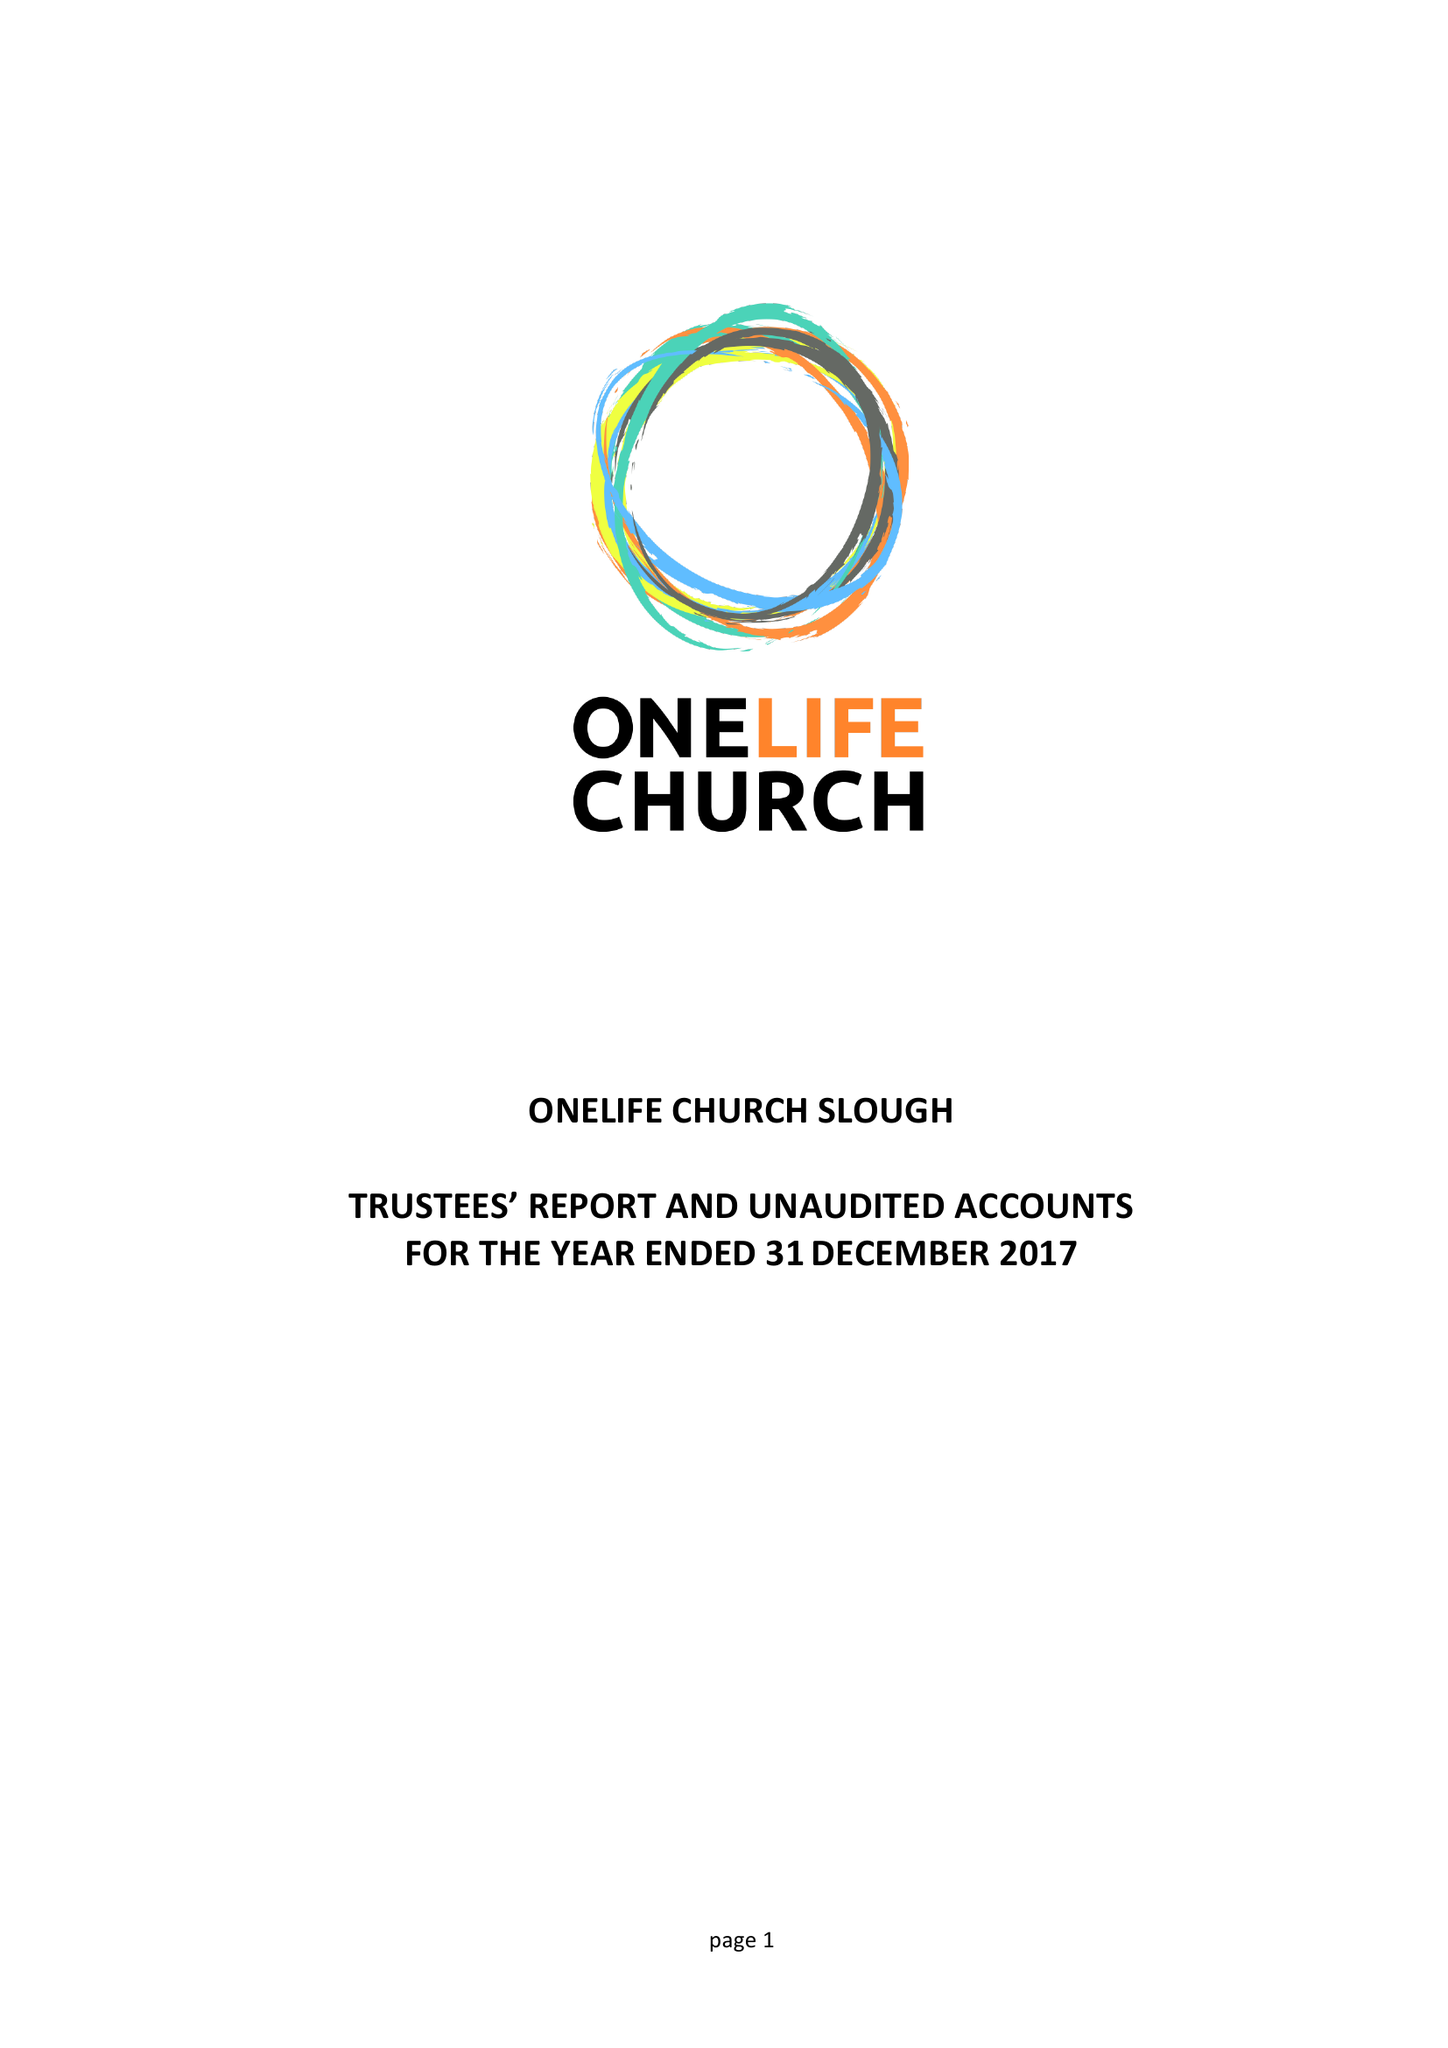What is the value for the address__postcode?
Answer the question using a single word or phrase. SL2 1TY 